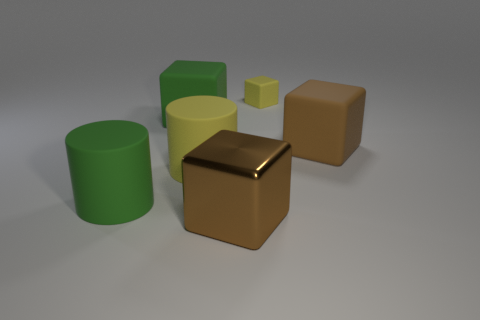What number of yellow things are either small cubes or large metallic blocks?
Your answer should be very brief. 1. Do the large green cylinder and the cube that is behind the green matte cube have the same material?
Make the answer very short. Yes. Is the number of rubber objects to the left of the yellow matte cylinder the same as the number of yellow blocks that are to the left of the large brown shiny cube?
Provide a short and direct response. No. There is a green block; is it the same size as the rubber cube to the right of the small yellow matte object?
Offer a terse response. Yes. Are there more blocks that are left of the small thing than small brown shiny spheres?
Your answer should be very brief. Yes. What number of yellow cubes are the same size as the green matte cube?
Your response must be concise. 0. There is a yellow thing that is left of the small yellow rubber block; is its size the same as the yellow rubber thing on the right side of the large metallic thing?
Offer a very short reply. No. Are there more big matte objects that are behind the yellow cylinder than large cylinders behind the small rubber block?
Your answer should be very brief. Yes. How many yellow objects are the same shape as the large brown shiny object?
Your response must be concise. 1. What material is the other brown block that is the same size as the metallic cube?
Your response must be concise. Rubber. 